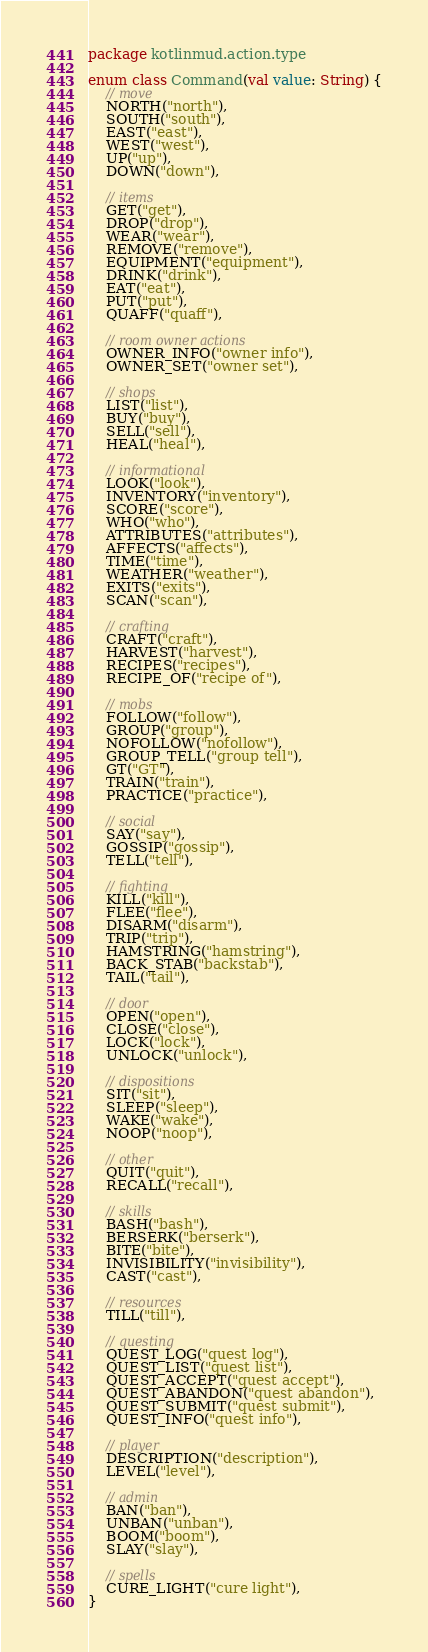Convert code to text. <code><loc_0><loc_0><loc_500><loc_500><_Kotlin_>package kotlinmud.action.type

enum class Command(val value: String) {
    // move
    NORTH("north"),
    SOUTH("south"),
    EAST("east"),
    WEST("west"),
    UP("up"),
    DOWN("down"),

    // items
    GET("get"),
    DROP("drop"),
    WEAR("wear"),
    REMOVE("remove"),
    EQUIPMENT("equipment"),
    DRINK("drink"),
    EAT("eat"),
    PUT("put"),
    QUAFF("quaff"),

    // room owner actions
    OWNER_INFO("owner info"),
    OWNER_SET("owner set"),

    // shops
    LIST("list"),
    BUY("buy"),
    SELL("sell"),
    HEAL("heal"),

    // informational
    LOOK("look"),
    INVENTORY("inventory"),
    SCORE("score"),
    WHO("who"),
    ATTRIBUTES("attributes"),
    AFFECTS("affects"),
    TIME("time"),
    WEATHER("weather"),
    EXITS("exits"),
    SCAN("scan"),

    // crafting
    CRAFT("craft"),
    HARVEST("harvest"),
    RECIPES("recipes"),
    RECIPE_OF("recipe of"),

    // mobs
    FOLLOW("follow"),
    GROUP("group"),
    NOFOLLOW("nofollow"),
    GROUP_TELL("group tell"),
    GT("GT"),
    TRAIN("train"),
    PRACTICE("practice"),

    // social
    SAY("say"),
    GOSSIP("gossip"),
    TELL("tell"),

    // fighting
    KILL("kill"),
    FLEE("flee"),
    DISARM("disarm"),
    TRIP("trip"),
    HAMSTRING("hamstring"),
    BACK_STAB("backstab"),
    TAIL("tail"),

    // door
    OPEN("open"),
    CLOSE("close"),
    LOCK("lock"),
    UNLOCK("unlock"),

    // dispositions
    SIT("sit"),
    SLEEP("sleep"),
    WAKE("wake"),
    NOOP("noop"),

    // other
    QUIT("quit"),
    RECALL("recall"),

    // skills
    BASH("bash"),
    BERSERK("berserk"),
    BITE("bite"),
    INVISIBILITY("invisibility"),
    CAST("cast"),

    // resources
    TILL("till"),

    // questing
    QUEST_LOG("quest log"),
    QUEST_LIST("quest list"),
    QUEST_ACCEPT("quest accept"),
    QUEST_ABANDON("quest abandon"),
    QUEST_SUBMIT("quest submit"),
    QUEST_INFO("quest info"),

    // player
    DESCRIPTION("description"),
    LEVEL("level"),

    // admin
    BAN("ban"),
    UNBAN("unban"),
    BOOM("boom"),
    SLAY("slay"),

    // spells
    CURE_LIGHT("cure light"),
}
</code> 